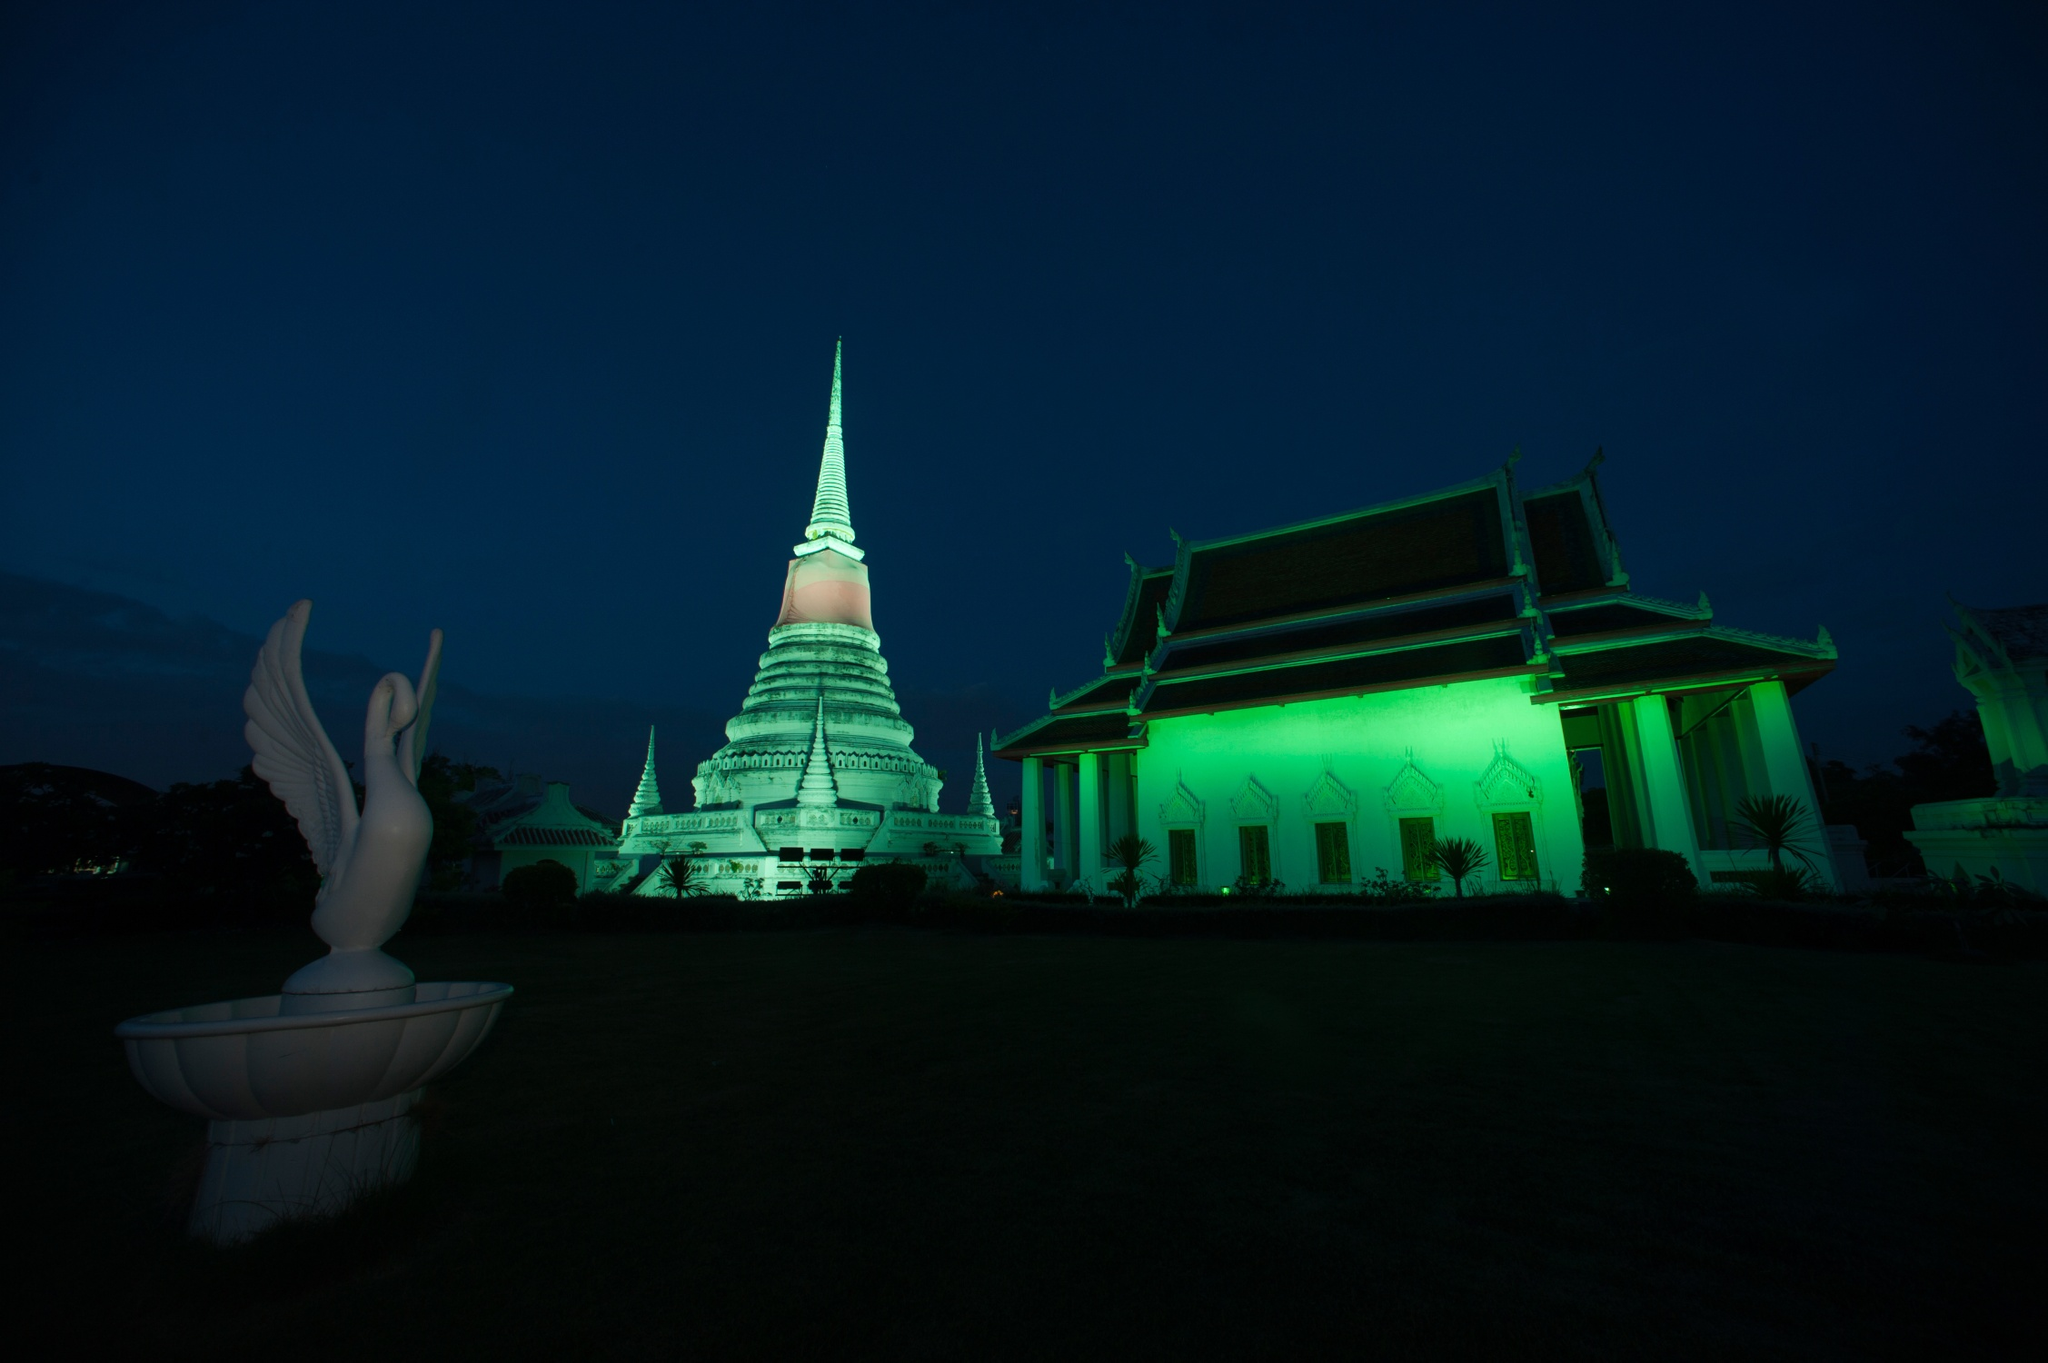What if the temple came to life at night, what could happen? If the temple came to life at night, the statues might begin to move, taking on their true forms. The bird statue could take flight, soaring above the temple, casting a protective aura over the grounds. The green lights might pulse with energy, illuminating the entire area in a gentle, magical glow. Mystical creatures from Thai folklore could emerge, engaging in a silent, ethereal dance, unseen during the daylight. The air would be filled with a soft melody, possibly the sounds of an ancient hymn, bringing with it a sense of peace and otherworldly presence. 